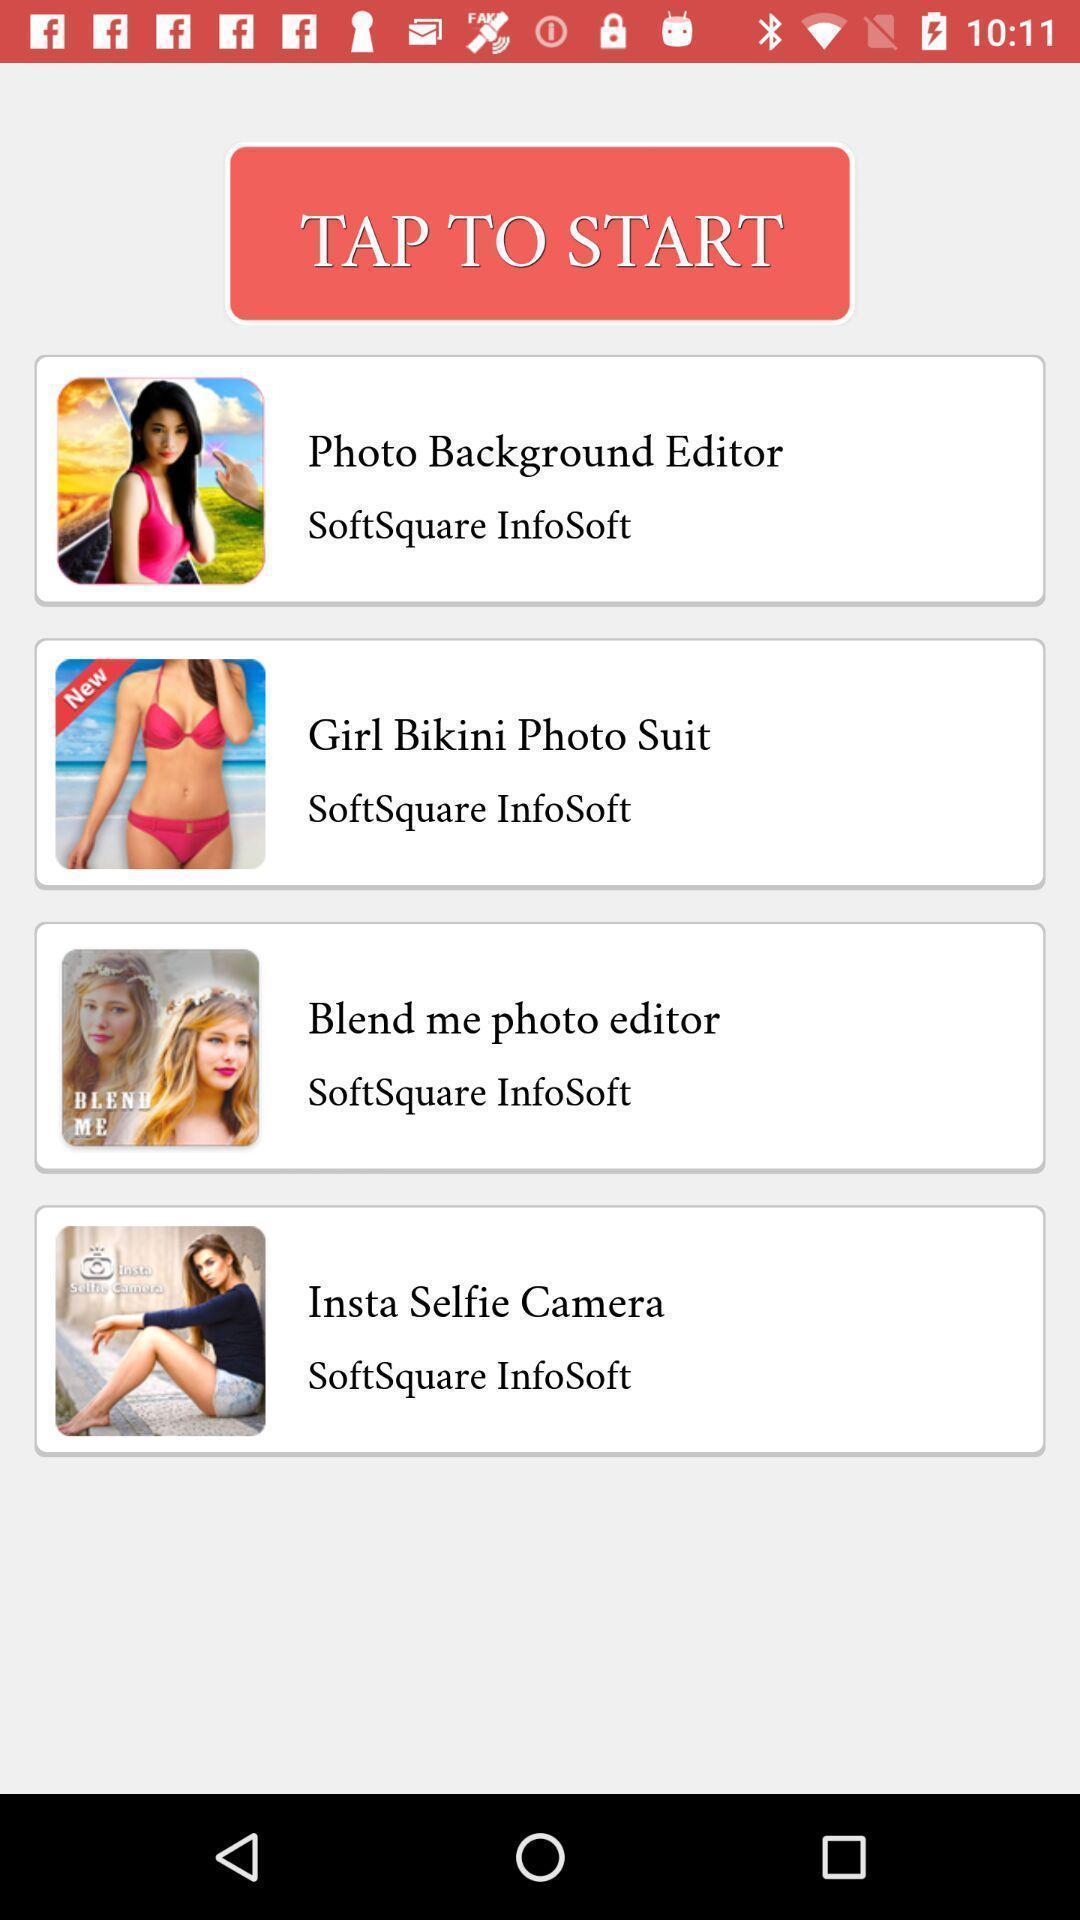Tell me what you see in this picture. Start page. 